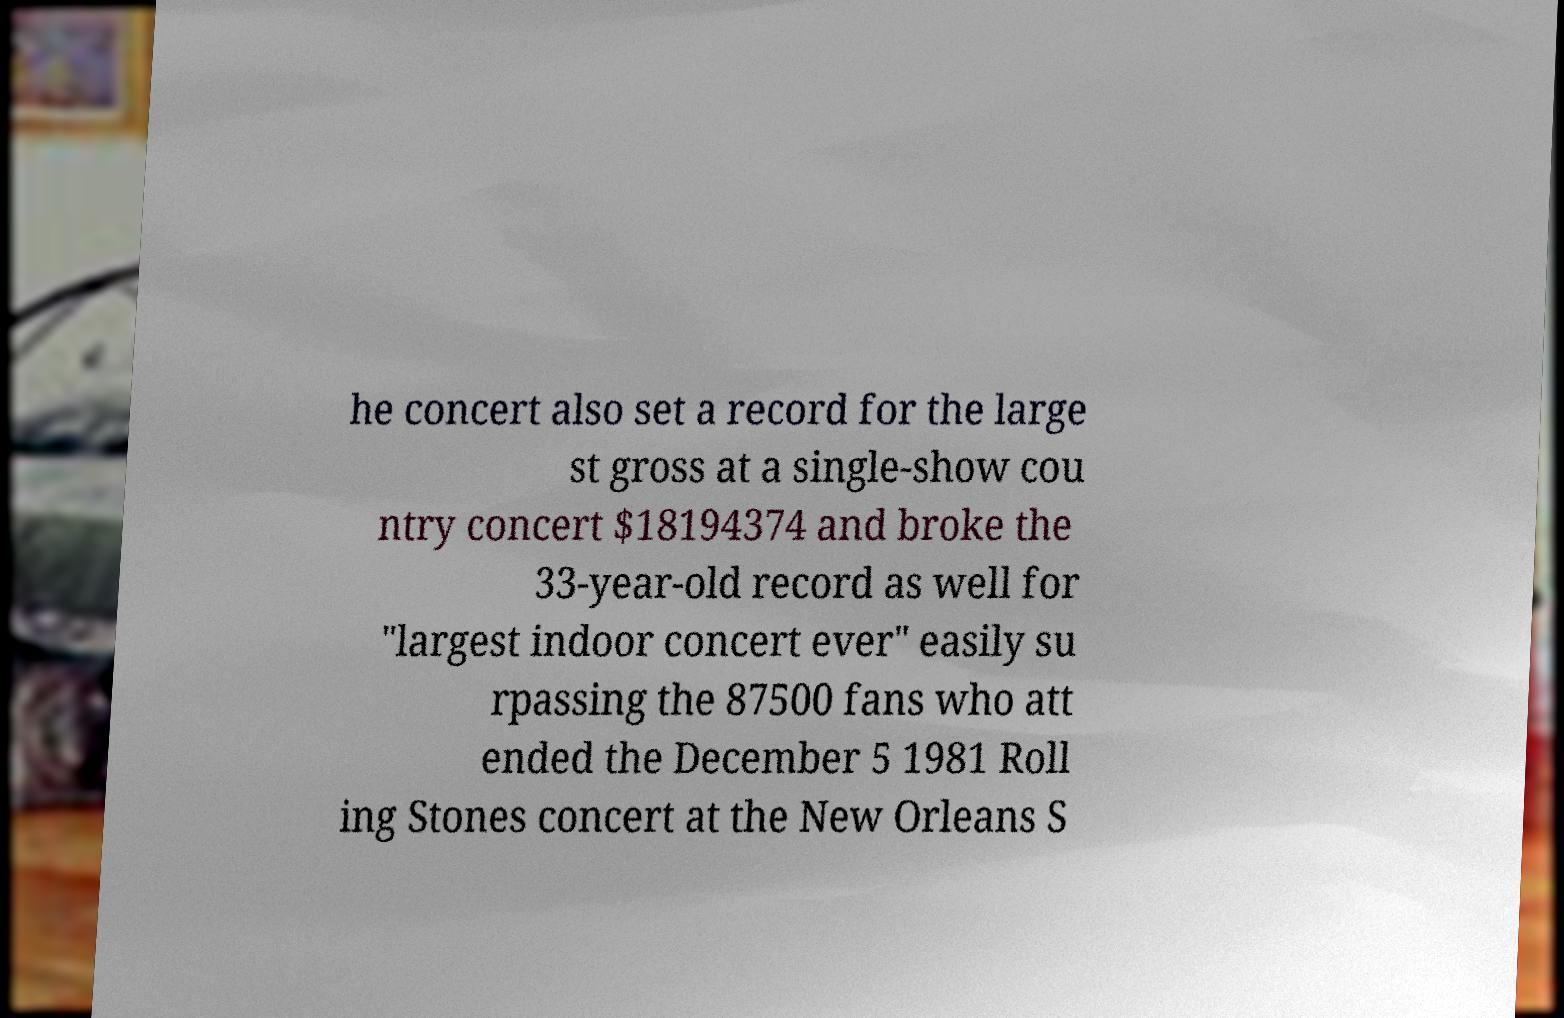Can you read and provide the text displayed in the image?This photo seems to have some interesting text. Can you extract and type it out for me? he concert also set a record for the large st gross at a single-show cou ntry concert $18194374 and broke the 33-year-old record as well for "largest indoor concert ever" easily su rpassing the 87500 fans who att ended the December 5 1981 Roll ing Stones concert at the New Orleans S 